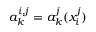Convert formula to latex. <formula><loc_0><loc_0><loc_500><loc_500>a _ { k } ^ { i , j } = a _ { k } ^ { j } ( x _ { i } ^ { j } )</formula> 